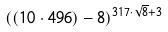<formula> <loc_0><loc_0><loc_500><loc_500>( ( 1 0 \cdot 4 9 6 ) - 8 ) ^ { 3 1 7 \cdot \sqrt { 8 } + 3 }</formula> 